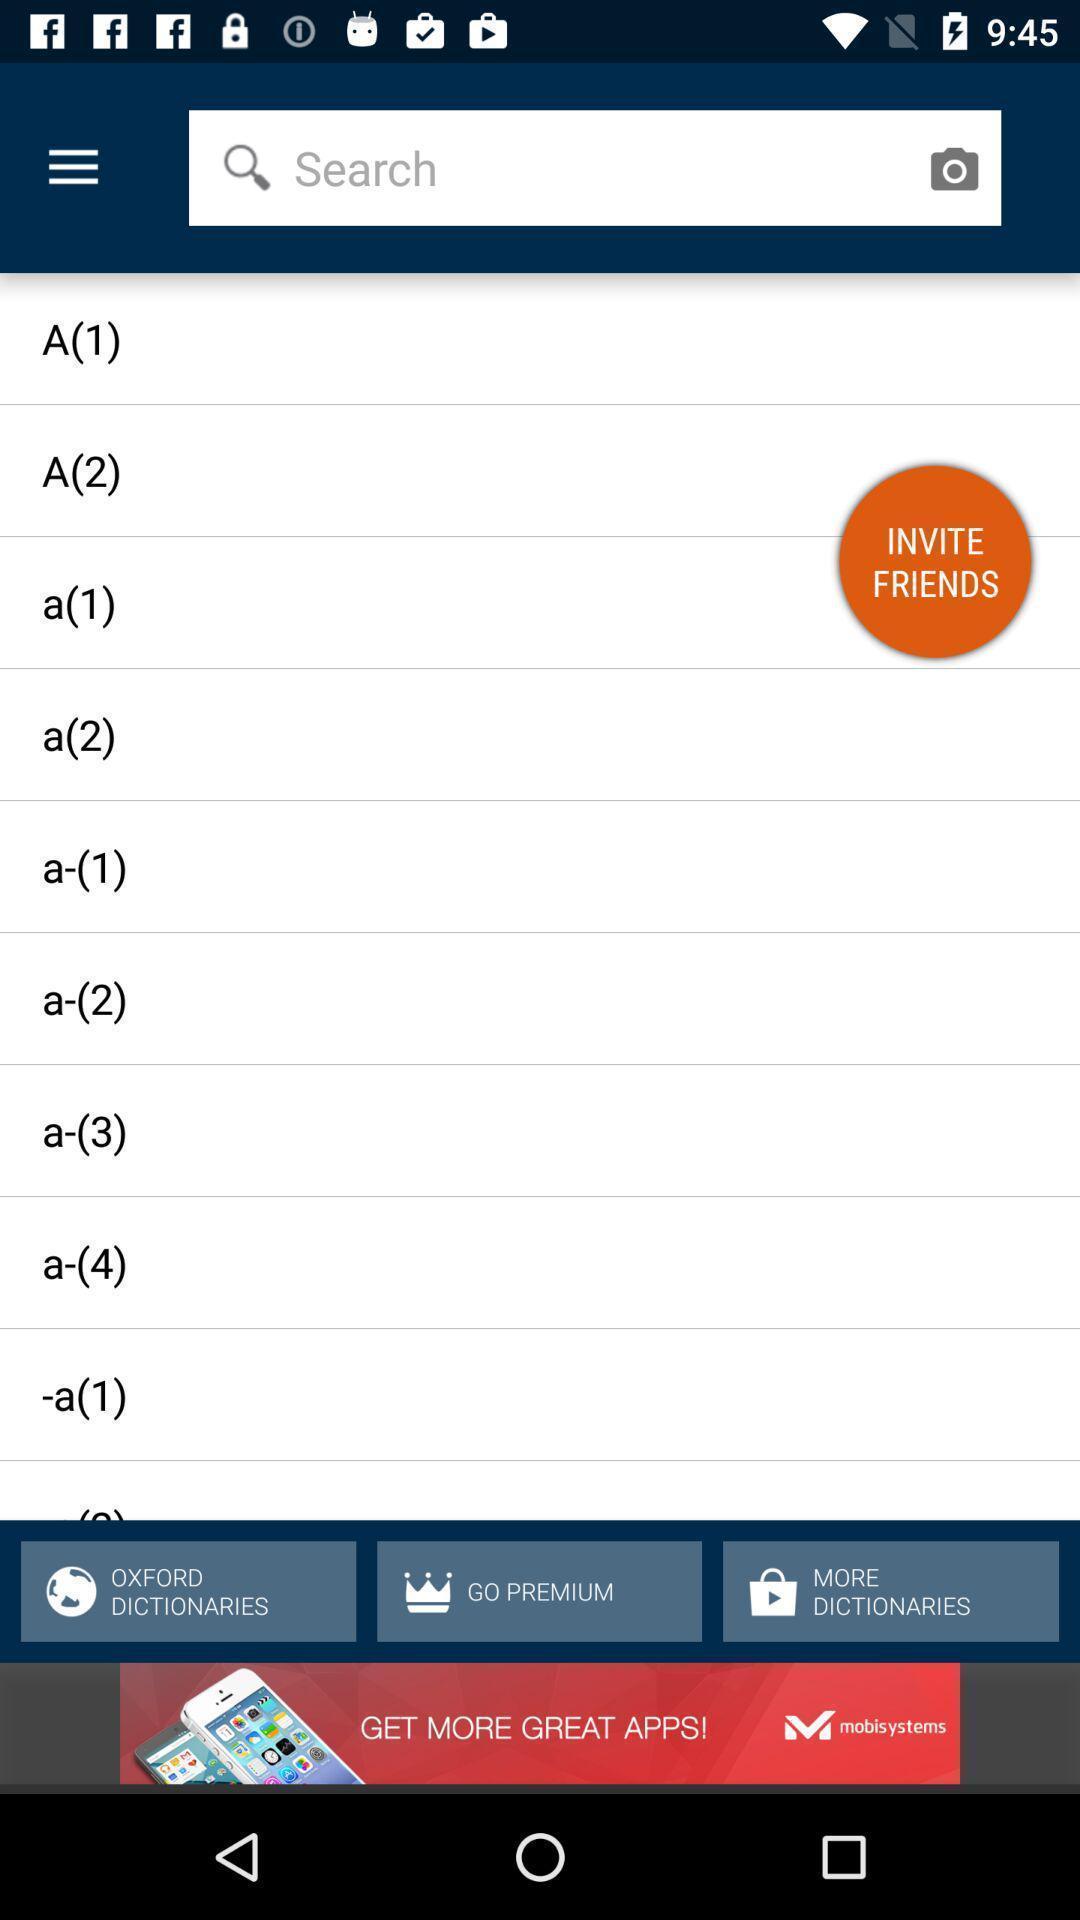Summarize the information in this screenshot. Search bar to search words in dictionary app. 